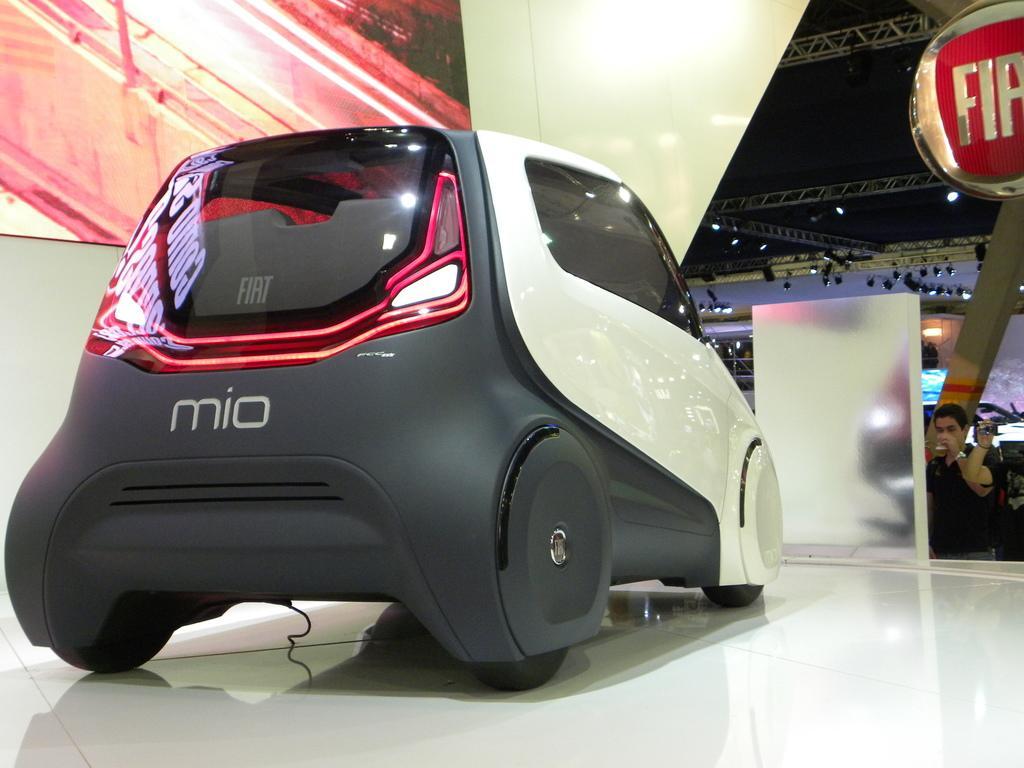How would you summarize this image in a sentence or two? In this picture there is a device and board on the table. At the back there is a person standing and holding the glass and there is a person standing and holding the device. At the top there are lights and there is a board and there is a text on the board. At the back there is a board and there are group of people. 